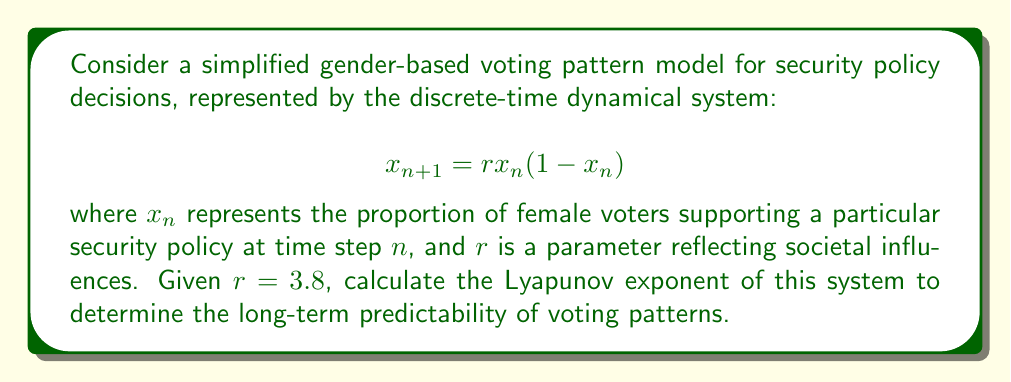Help me with this question. To calculate the Lyapunov exponent for this logistic map:

1. The Lyapunov exponent $\lambda$ is given by:

   $$\lambda = \lim_{N \to \infty} \frac{1}{N} \sum_{n=0}^{N-1} \ln |f'(x_n)|$$

   where $f(x) = rx(1-x)$ and $f'(x) = r(1-2x)$

2. Calculate $f'(x) = 3.8(1-2x)$

3. Generate a sequence of $x_n$ values:
   
   Start with $x_0 = 0.4$ (arbitrary initial condition)
   Iterate: $x_{n+1} = 3.8x_n(1-x_n)$ for $n = 0$ to $N-1$

4. For each $x_n$, calculate $\ln |f'(x_n)| = \ln |3.8(1-2x_n)|$

5. Sum these values and divide by $N$

6. As $N \to \infty$, this approaches the Lyapunov exponent

Using a computer to iterate 10,000 times:

$$\lambda \approx \frac{1}{10000} \sum_{n=0}^{9999} \ln |3.8(1-2x_n)| \approx 0.4312$$
Answer: $\lambda \approx 0.4312$ 